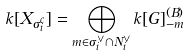<formula> <loc_0><loc_0><loc_500><loc_500>k [ X _ { \sigma _ { i } ^ { c } } ] = \bigoplus _ { m \in \sigma _ { i } ^ { \vee } \cap N _ { i } ^ { \vee } } k [ G ] ^ { ( B ) } _ { - m }</formula> 